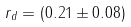<formula> <loc_0><loc_0><loc_500><loc_500>r _ { d } = ( 0 . 2 1 \pm 0 . 0 8 )</formula> 